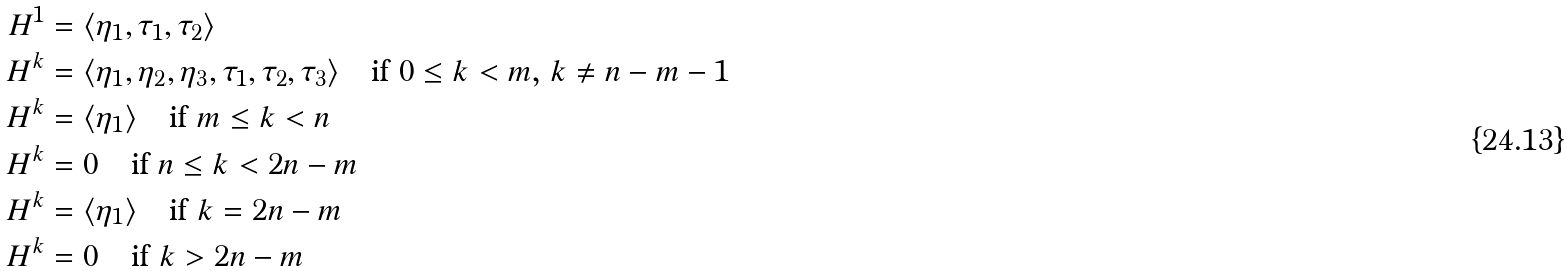Convert formula to latex. <formula><loc_0><loc_0><loc_500><loc_500>H ^ { 1 } & = \langle \eta _ { 1 } , \tau _ { 1 } , \tau _ { 2 } \rangle \\ H ^ { k } & = \langle \eta _ { 1 } , \eta _ { 2 } , \eta _ { 3 } , \tau _ { 1 } , \tau _ { 2 } , \tau _ { 3 } \rangle \quad \text {if $0\leq k<m$, $k\ne n-m-1$} \\ H ^ { k } & = \langle \eta _ { 1 } \rangle \quad \text {if $m\leq k<n$} \\ H ^ { k } & = 0 \quad \text {if $n\leq k<2n-m$} \\ H ^ { k } & = \langle \eta _ { 1 } \rangle \quad \text {if $k=2n-m$} \\ H ^ { k } & = 0 \quad \text {if $k>2n-m$}</formula> 